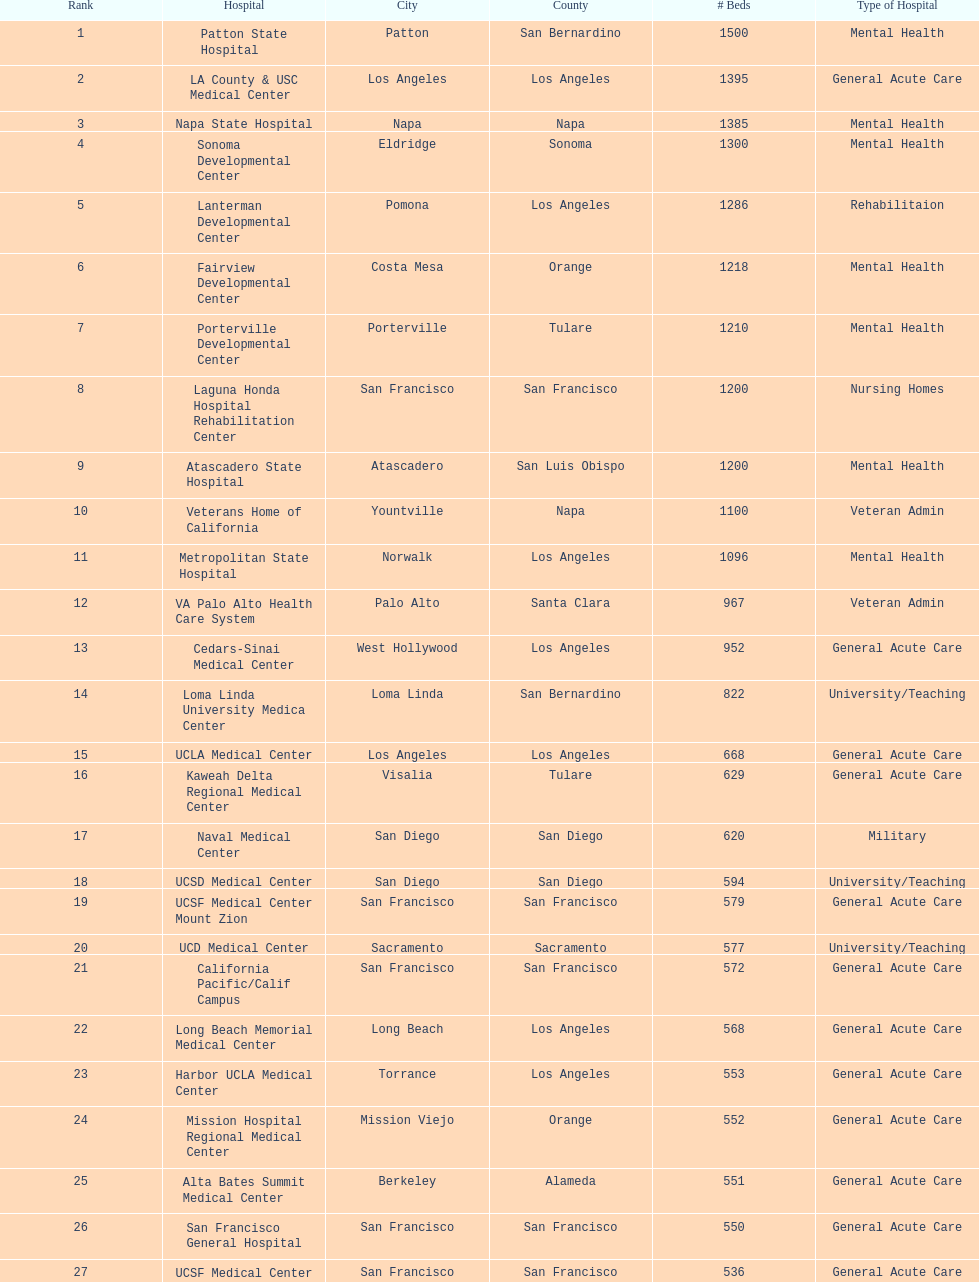How much larger (in number of beds) was the largest hospital in california than the 50th largest? 1071. 